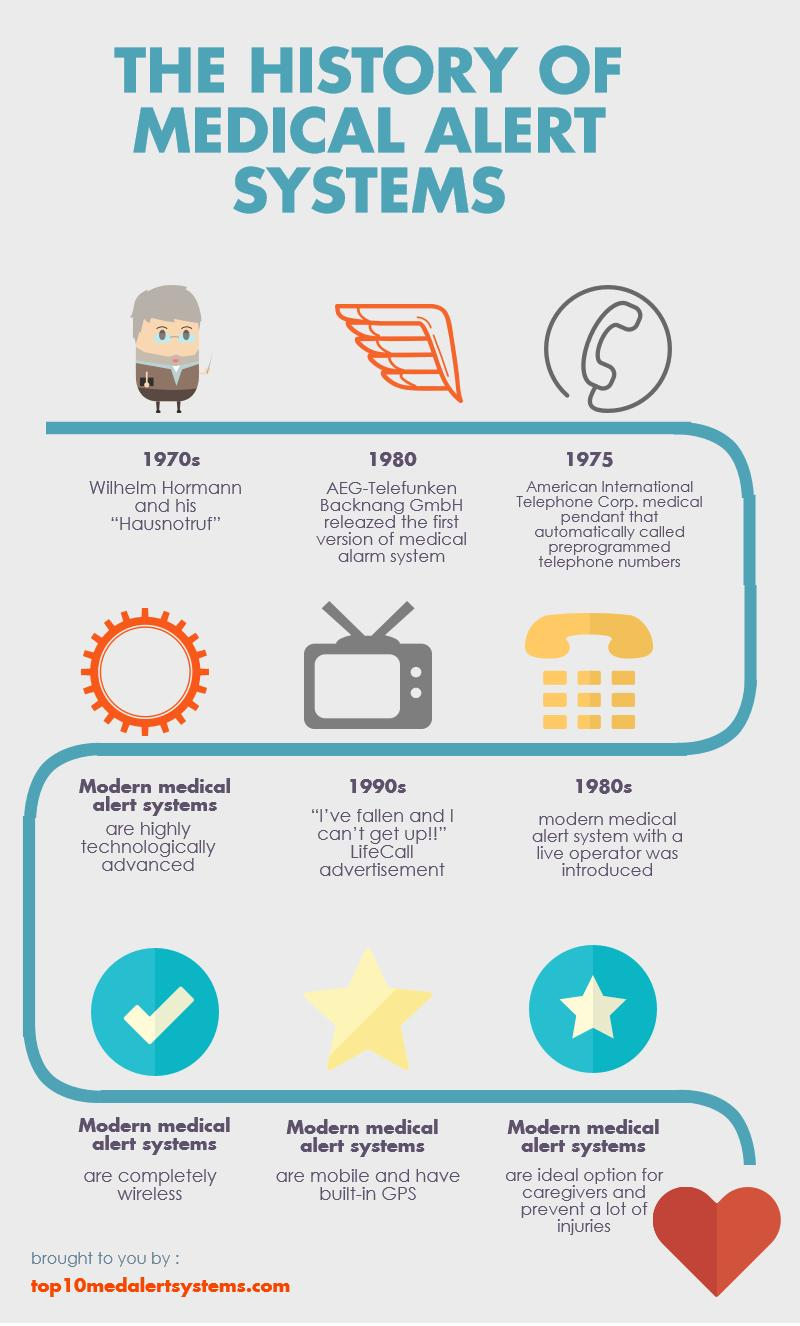Point out several critical features in this image. Current medical alert systems are completely wireless, providing users with the convenience and reliability they need in the event of an emergency. Mobile and modern medical alert systems have built-in GPS capabilities, enabling users to quickly and easily access their location in the event of an emergency. The modern medical alert system with a live operator was introduced in the 1980s. 